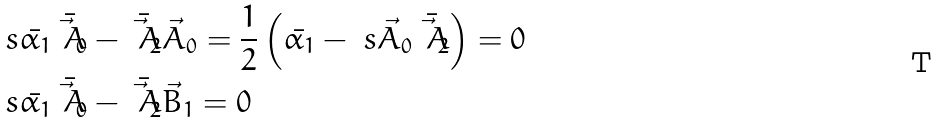Convert formula to latex. <formula><loc_0><loc_0><loc_500><loc_500>& \ s { \bar { \alpha _ { 1 } } \bar { \vec { A } _ { 0 } } - \bar { \vec { A } _ { 2 } } } { \vec { A } _ { 0 } } = \frac { 1 } { 2 } \left ( \bar { \alpha _ { 1 } } - \ s { \vec { A } _ { 0 } } { \bar { \vec { A } _ { 2 } } } \right ) = 0 \\ & \ s { \bar { \alpha _ { 1 } } \bar { \vec { A } _ { 0 } } - \bar { \vec { A } _ { 2 } } } { \vec { B } _ { 1 } } = 0</formula> 